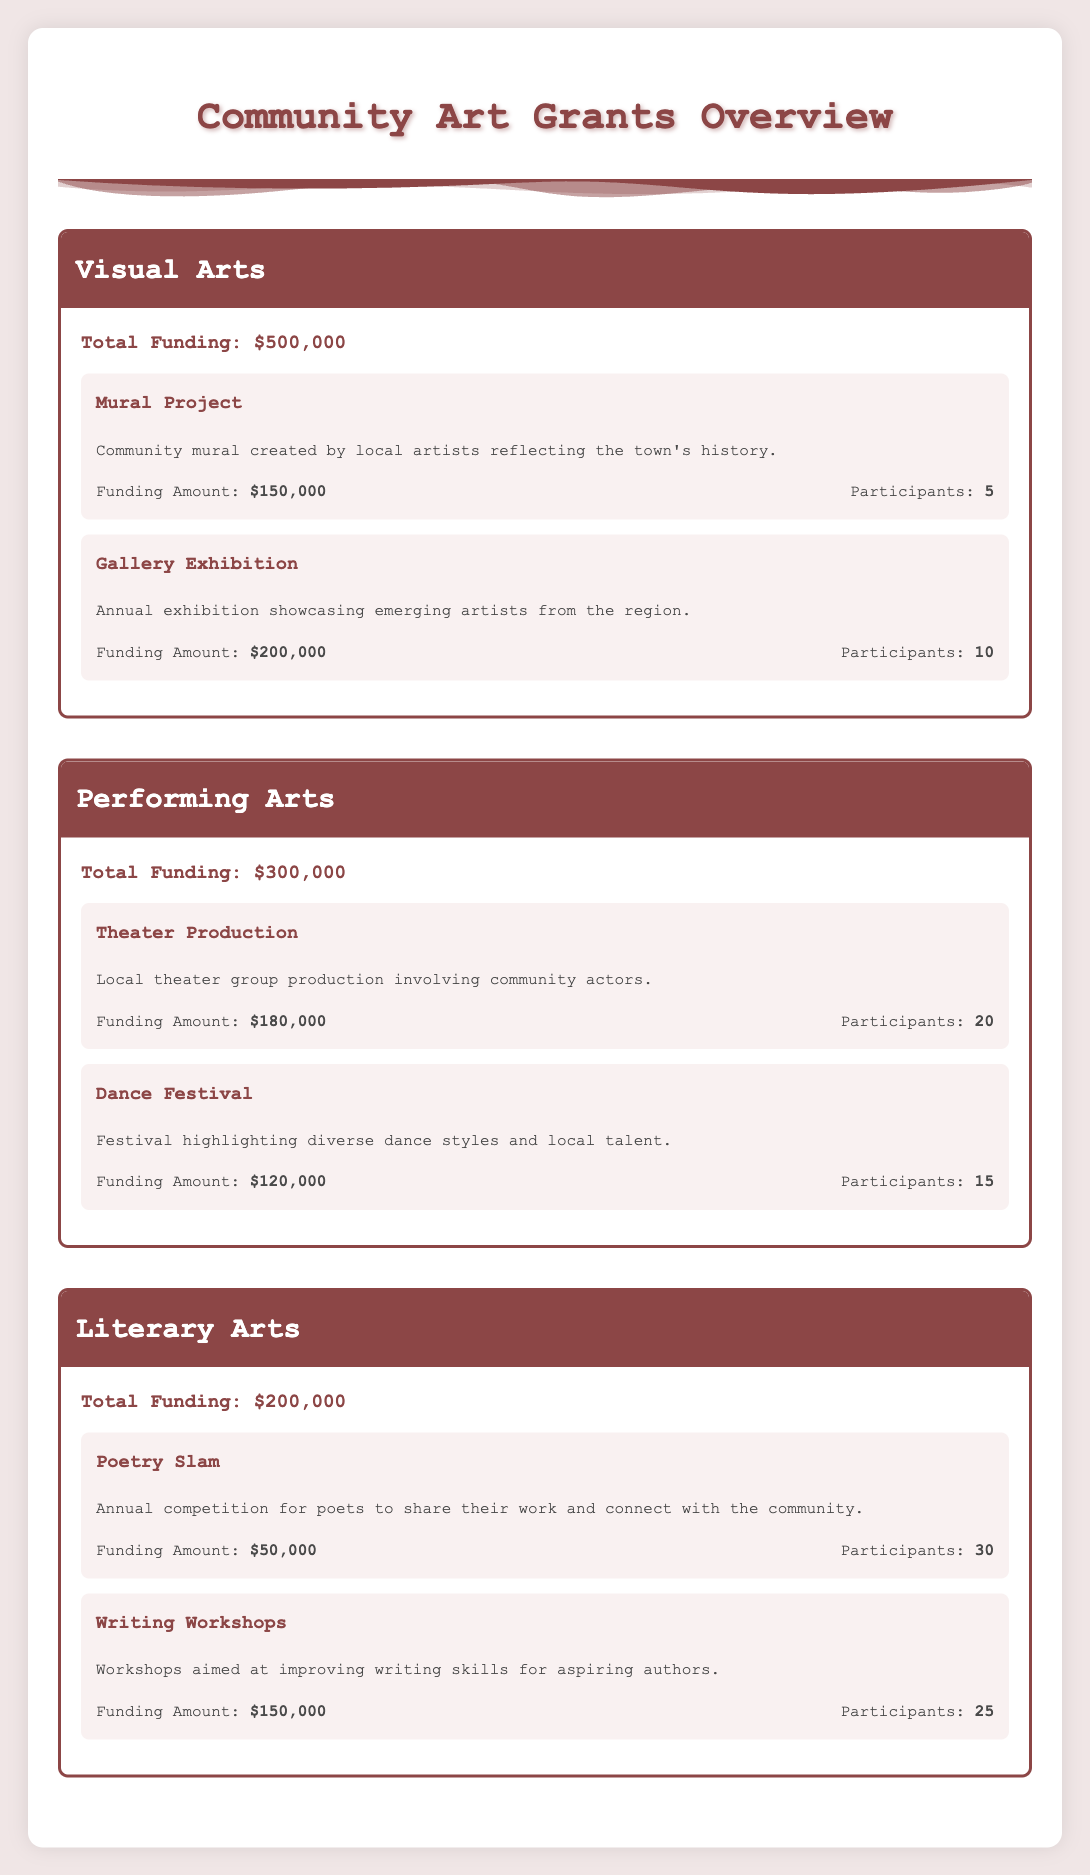What is the total funding for Visual Arts? The total funding for Visual Arts is explicitly stated in the table under the Visual Arts section, which shows a value of $500,000.
Answer: $500,000 How much funding is allocated to the Gallery Exhibition project? The funding amount for the Gallery Exhibition project is provided directly in the table, listed as $200,000.
Answer: $200,000 Is the funding for the Poetry Slam greater than the funding for the Mural Project? The funding for the Poetry Slam is stated as $50,000, and the Mural Project funding is $150,000. Since 50,000 is less than 150,000, the statement is false.
Answer: No What is the total number of participants across all projects in the Performing Arts category? The number of participants in Theater Production is 20 and in Dance Festival is 15. Adding these gives 20 + 15 = 35 participants in total.
Answer: 35 Which project has the highest funding in the Literary Arts category? In the Literary Arts category, the two projects listed are the Poetry Slam with $50,000 and the Writing Workshops with $150,000. The Writing Workshops has the higher funding amount.
Answer: Writing Workshops What is the average funding amount for projects under Visual Arts? The projects in Visual Arts are Mural Project ($150,000) and Gallery Exhibition ($200,000). Their total funding is 150,000 + 200,000 = 350,000. There are 2 projects, so the average funding is 350,000 / 2 = 175,000.
Answer: $175,000 Are there more participants in the Writing Workshops than in the Dance Festival? The Writing Workshops has 25 participants while the Dance Festival has 15. Since 25 is greater than 15, the statement is true.
Answer: Yes What is the total funding for all three categories? The total funding for Visual Arts is $500,000, for Performing Arts is $300,000, and for Literary Arts is $200,000. Adding these gives 500,000 + 300,000 + 200,000 = 1,000,000 total funding across all categories.
Answer: $1,000,000 How many more participants does the Theater Production have compared to the Mural Project? The Theater Production has 20 participants and the Mural Project has 5 participants. The difference is 20 - 5 = 15 more participants in Theater Production.
Answer: 15 What is the combined funding for the Poetry Slam and Dance Festival? The funding for the Poetry Slam is $50,000 and for the Dance Festival is $120,000. Adding these funds together gives 50,000 + 120,000 = 170,000.
Answer: $170,000 